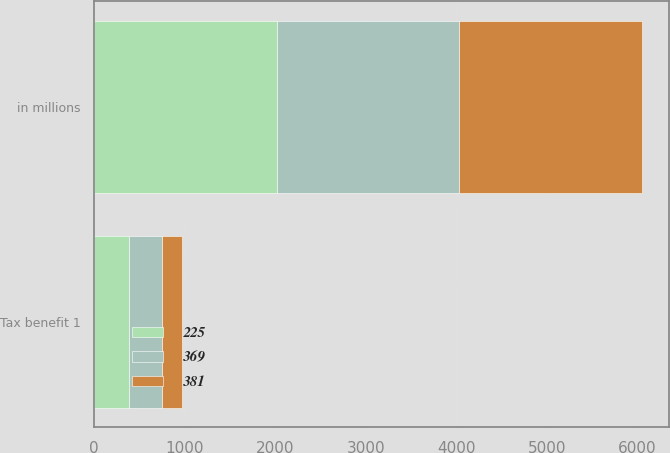Convert chart. <chart><loc_0><loc_0><loc_500><loc_500><stacked_bar_chart><ecel><fcel>in millions<fcel>Tax benefit 1<nl><fcel>381<fcel>2017<fcel>225<nl><fcel>225<fcel>2016<fcel>381<nl><fcel>369<fcel>2015<fcel>369<nl></chart> 